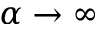<formula> <loc_0><loc_0><loc_500><loc_500>\alpha \to \infty</formula> 